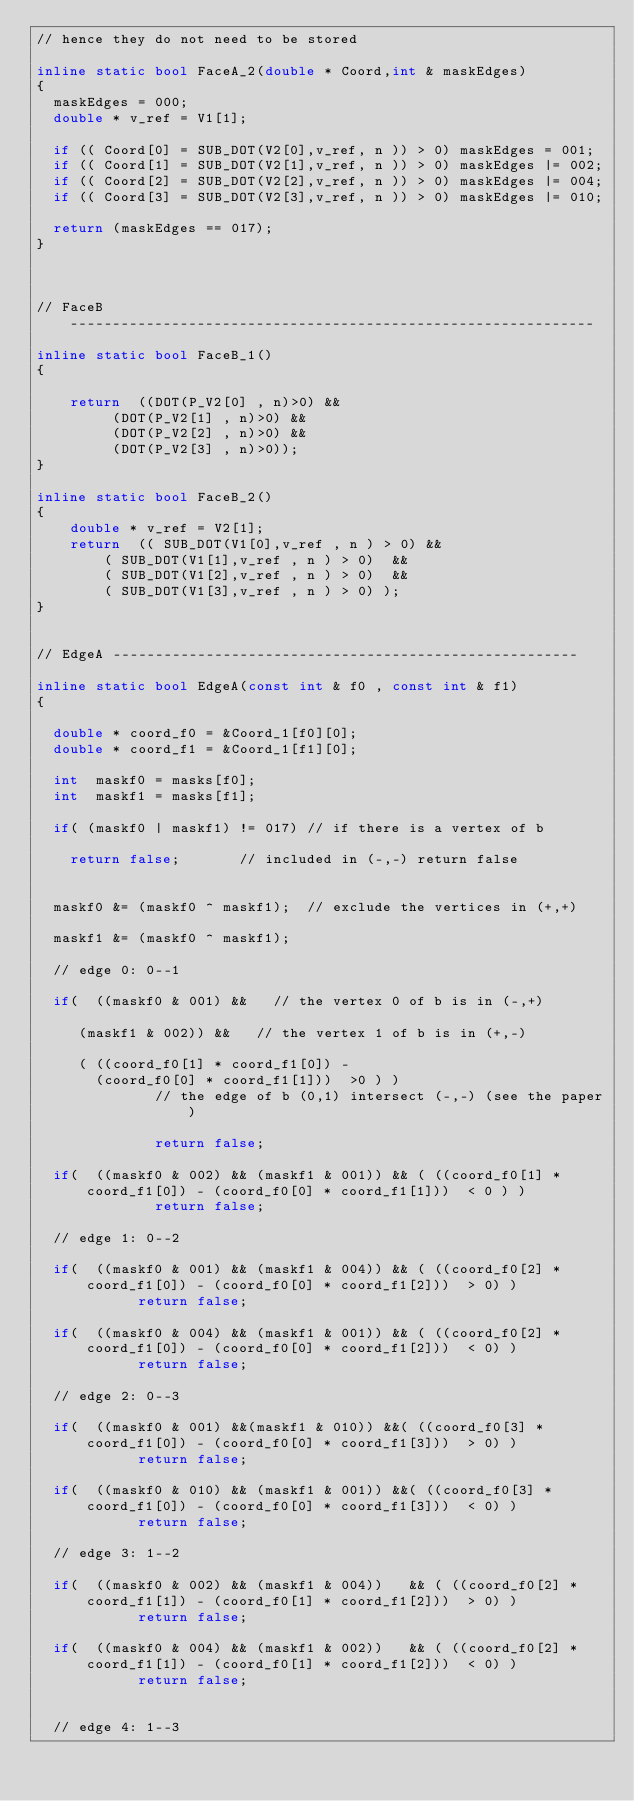Convert code to text. <code><loc_0><loc_0><loc_500><loc_500><_C++_>// hence they do not need to be stored

inline static bool FaceA_2(double * Coord,int & maskEdges)
{
  maskEdges = 000;
  double * v_ref = V1[1];

  if (( Coord[0] = SUB_DOT(V2[0],v_ref, n )) > 0) maskEdges = 001;  
  if (( Coord[1] = SUB_DOT(V2[1],v_ref, n )) > 0) maskEdges |= 002; 
  if (( Coord[2] = SUB_DOT(V2[2],v_ref, n )) > 0) maskEdges |= 004; 
  if (( Coord[3] = SUB_DOT(V2[3],v_ref, n )) > 0) maskEdges |= 010; 

  return (maskEdges == 017);  
}



// FaceB --------------------------------------------------------------

inline static bool FaceB_1()
{

    return  ((DOT(P_V2[0] , n)>0) &&        
         (DOT(P_V2[1] , n)>0) &&  
         (DOT(P_V2[2] , n)>0) &&  
         (DOT(P_V2[3] , n)>0));
}

inline static bool FaceB_2()
{
    double * v_ref = V2[1];
    return  (( SUB_DOT(V1[0],v_ref , n ) > 0) &&
        ( SUB_DOT(V1[1],v_ref , n ) > 0)  &&
        ( SUB_DOT(V1[2],v_ref , n ) > 0)  &&
        ( SUB_DOT(V1[3],v_ref , n ) > 0) );
}


// EdgeA -------------------------------------------------------

inline static bool EdgeA(const int & f0 , const int & f1)
{

  double * coord_f0 = &Coord_1[f0][0];
  double * coord_f1 = &Coord_1[f1][0];

  int  maskf0 = masks[f0];
  int  maskf1 = masks[f1];

  if( (maskf0 | maskf1) != 017) // if there is a vertex of b 

    return false;       // included in (-,-) return false


  maskf0 &= (maskf0 ^ maskf1);  // exclude the vertices in (+,+)

  maskf1 &= (maskf0 ^ maskf1);

  // edge 0: 0--1 

  if(  ((maskf0 & 001) &&   // the vertex 0 of b is in (-,+) 

     (maskf1 & 002)) &&   // the vertex 1 of b is in (+,-)

     ( ((coord_f0[1] * coord_f1[0]) - 
       (coord_f0[0] * coord_f1[1]))  >0 ) )
              // the edge of b (0,1) intersect (-,-) (see the paper)

              return false;   

  if(  ((maskf0 & 002) && (maskf1 & 001)) && ( ((coord_f0[1] * coord_f1[0]) - (coord_f0[0] * coord_f1[1]))  < 0 ) )
              return false;   
      
  // edge 1: 0--2 

  if(  ((maskf0 & 001) && (maskf1 & 004)) && ( ((coord_f0[2] * coord_f1[0]) - (coord_f0[0] * coord_f1[2]))  > 0) )
            return false; 

  if(  ((maskf0 & 004) && (maskf1 & 001)) && ( ((coord_f0[2] * coord_f1[0]) - (coord_f0[0] * coord_f1[2]))  < 0) )
            return false; 
    
  // edge 2: 0--3 

  if(  ((maskf0 & 001) &&(maskf1 & 010)) &&( ((coord_f0[3] * coord_f1[0]) - (coord_f0[0] * coord_f1[3]))  > 0) )
            return false;
  
  if(  ((maskf0 & 010) && (maskf1 & 001)) &&( ((coord_f0[3] * coord_f1[0]) - (coord_f0[0] * coord_f1[3]))  < 0) )
            return false; 

  // edge 3: 1--2 

  if(  ((maskf0 & 002) && (maskf1 & 004))   && ( ((coord_f0[2] * coord_f1[1]) - (coord_f0[1] * coord_f1[2]))  > 0) )
            return false;

  if(  ((maskf0 & 004) && (maskf1 & 002))   && ( ((coord_f0[2] * coord_f1[1]) - (coord_f0[1] * coord_f1[2]))  < 0) )
            return false;
    
    
  // edge 4: 1--3 
</code> 